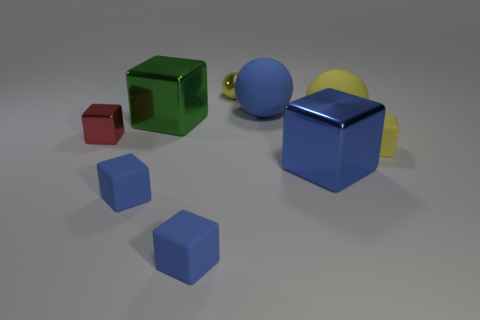Subtract all green cylinders. How many yellow balls are left? 2 Subtract all green blocks. How many blocks are left? 5 Subtract all red cubes. How many cubes are left? 5 Add 1 big yellow matte spheres. How many objects exist? 10 Subtract all yellow blocks. Subtract all purple cylinders. How many blocks are left? 5 Subtract all spheres. How many objects are left? 6 Add 5 small brown rubber balls. How many small brown rubber balls exist? 5 Subtract 0 purple cylinders. How many objects are left? 9 Subtract all tiny cyan objects. Subtract all small red things. How many objects are left? 8 Add 3 large metal blocks. How many large metal blocks are left? 5 